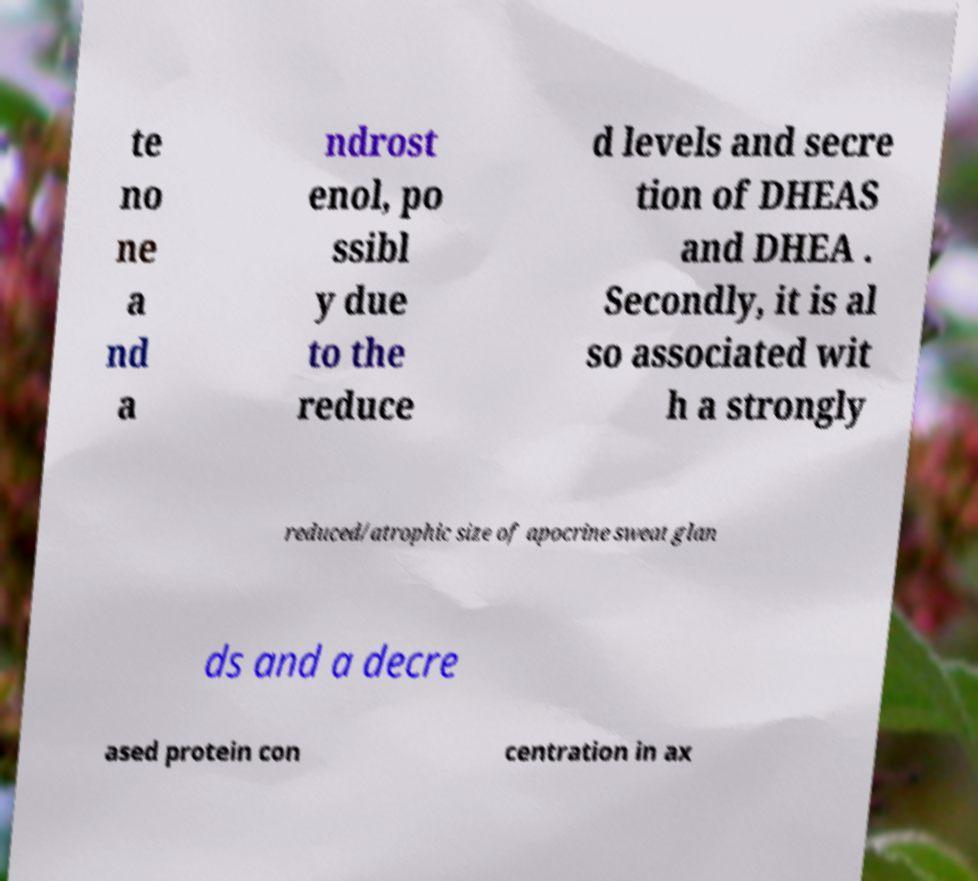Could you extract and type out the text from this image? te no ne a nd a ndrost enol, po ssibl y due to the reduce d levels and secre tion of DHEAS and DHEA . Secondly, it is al so associated wit h a strongly reduced/atrophic size of apocrine sweat glan ds and a decre ased protein con centration in ax 